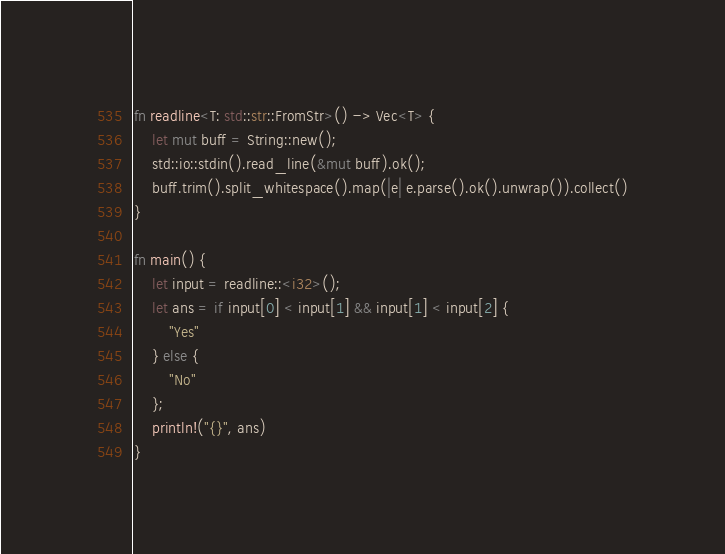Convert code to text. <code><loc_0><loc_0><loc_500><loc_500><_Rust_>fn readline<T: std::str::FromStr>() -> Vec<T> {
    let mut buff = String::new();
    std::io::stdin().read_line(&mut buff).ok();
    buff.trim().split_whitespace().map(|e| e.parse().ok().unwrap()).collect()
}

fn main() {
    let input = readline::<i32>();
    let ans = if input[0] < input[1] && input[1] < input[2] {
        "Yes"
    } else {
        "No"
    };
    println!("{}", ans)
}
</code> 